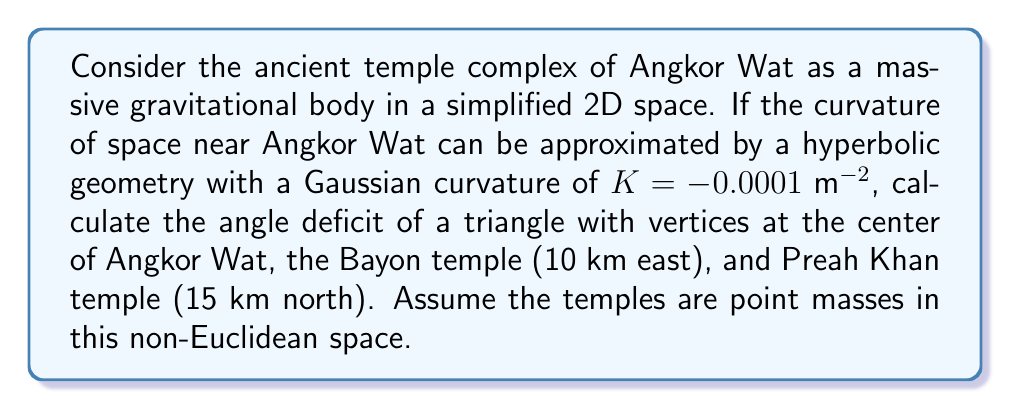Can you solve this math problem? Let's approach this step-by-step:

1) In hyperbolic geometry, the sum of angles in a triangle is less than 180°. The difference between 180° and the actual sum is called the angle deficit.

2) The Gauss-Bonnet theorem relates the area of a hyperbolic triangle to its angle deficit:

   $$A = (\pi - (\alpha + \beta + \gamma)) / |K|$$

   where $A$ is the area, $K$ is the Gaussian curvature, and $\alpha, \beta, \gamma$ are the angles of the triangle.

3) To find the area, we can use the hyperbolic version of Heron's formula:

   $$A = 4|K|^{-1} \arctan\sqrt{\tanh(s/2)\tanh((s-a)/2)\tanh((s-b)/2)\tanh((s-c)/2)}$$

   where $s = (a+b+c)/2$ is the semi-perimeter, and $a$, $b$, $c$ are the side lengths.

4) We need to calculate the side lengths. In hyperbolic geometry, we use the hyperbolic distance formula:

   $$d = \frac{1}{\sqrt{|K|}} \text{arcosh}(1 + |K|\frac{(x_2-x_1)^2 + (y_2-y_1)^2}{2})$$

5) Calculating the distances:
   - Angkor Wat to Bayon: $d_1 = \frac{1}{\sqrt{0.0001}} \text{arcosh}(1 + 0.0001\frac{10000^2}{2}) \approx 10.0001$ km
   - Angkor Wat to Preah Khan: $d_2 = \frac{1}{\sqrt{0.0001}} \text{arcosh}(1 + 0.0001\frac{15000^2}{2}) \approx 15.0003$ km
   - Bayon to Preah Khan: $d_3 = \frac{1}{\sqrt{0.0001}} \text{arcosh}(1 + 0.0001\frac{10000^2 + 15000^2}{2}) \approx 18.0273$ km

6) Now we can calculate the semi-perimeter:
   $s = (10.0001 + 15.0003 + 18.0273) / 2 \approx 21.5139$ km

7) Plugging into the hyperbolic Heron's formula:
   $$A \approx 4(0.0001)^{-1} \arctan\sqrt{\tanh(10.7569)\tanh(11.5138)\tanh(6.5136)\tanh(3.4866)} \approx 75.0014 \text{ km}^2$$

8) Finally, we can calculate the angle deficit:
   $$\text{Angle Deficit} = \pi - (\alpha + \beta + \gamma) = |K|A \approx 0.0001 * 75.0014 \approx 0.0075 \text{ radians} \approx 0.4297°$$
Answer: 0.4297° 